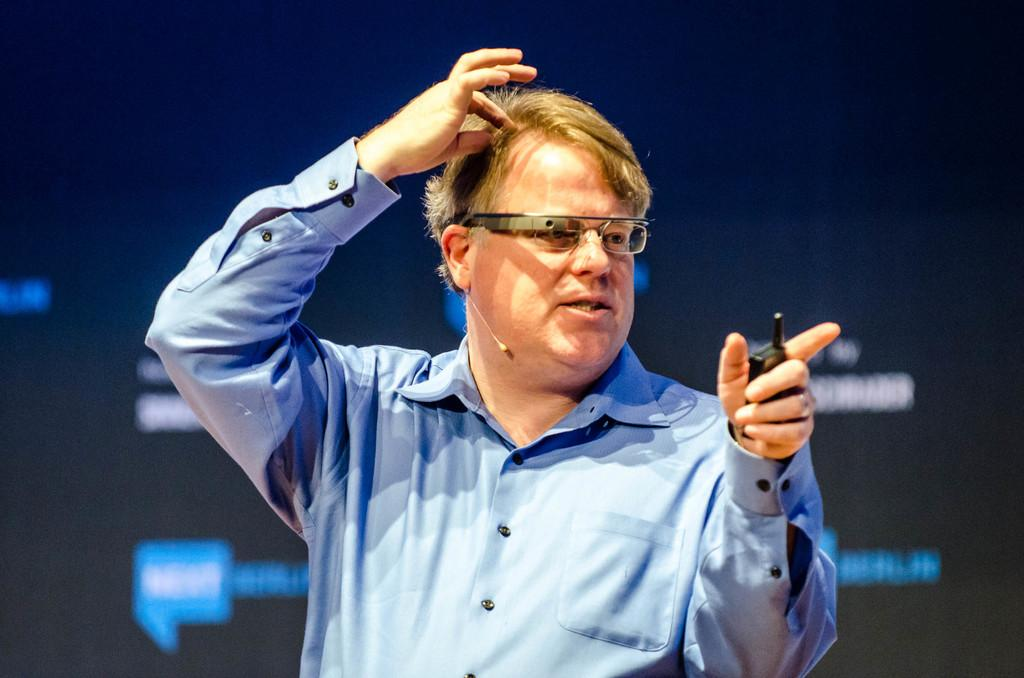Who is present in the image? There is a person in the image. What is the person wearing on their upper body? The person is wearing a blue shirt. What protective gear is the person wearing? The person is wearing goggles. What action is the person performing with their hand? The person is touching their hair with their hand. What device is the person holding? The person is holding a mobile phone. Can you see any ants crawling on the person's blue shirt in the image? There are no ants visible on the person's blue shirt in the image. What type of feather is the person using to touch their hair in the image? The person is not using a feather to touch their hair in the image; they are using their hand. 